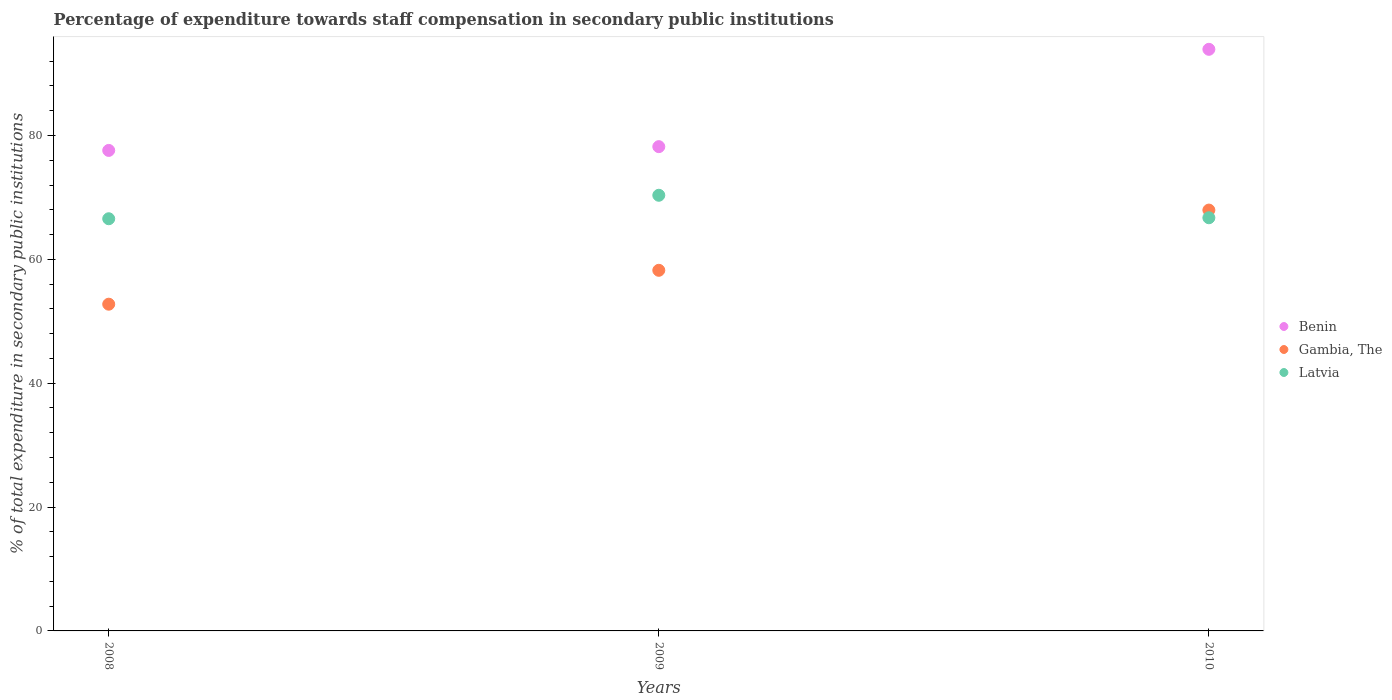Is the number of dotlines equal to the number of legend labels?
Make the answer very short. Yes. What is the percentage of expenditure towards staff compensation in Benin in 2010?
Provide a short and direct response. 93.91. Across all years, what is the maximum percentage of expenditure towards staff compensation in Gambia, The?
Your response must be concise. 67.96. Across all years, what is the minimum percentage of expenditure towards staff compensation in Latvia?
Your answer should be compact. 66.56. In which year was the percentage of expenditure towards staff compensation in Benin maximum?
Give a very brief answer. 2010. What is the total percentage of expenditure towards staff compensation in Latvia in the graph?
Offer a very short reply. 203.62. What is the difference between the percentage of expenditure towards staff compensation in Benin in 2009 and that in 2010?
Offer a terse response. -15.72. What is the difference between the percentage of expenditure towards staff compensation in Latvia in 2008 and the percentage of expenditure towards staff compensation in Benin in 2010?
Ensure brevity in your answer.  -27.36. What is the average percentage of expenditure towards staff compensation in Gambia, The per year?
Make the answer very short. 59.65. In the year 2009, what is the difference between the percentage of expenditure towards staff compensation in Gambia, The and percentage of expenditure towards staff compensation in Latvia?
Ensure brevity in your answer.  -12.12. What is the ratio of the percentage of expenditure towards staff compensation in Benin in 2009 to that in 2010?
Your answer should be very brief. 0.83. What is the difference between the highest and the second highest percentage of expenditure towards staff compensation in Latvia?
Provide a succinct answer. 3.63. What is the difference between the highest and the lowest percentage of expenditure towards staff compensation in Gambia, The?
Keep it short and to the point. 15.2. In how many years, is the percentage of expenditure towards staff compensation in Benin greater than the average percentage of expenditure towards staff compensation in Benin taken over all years?
Offer a terse response. 1. Is it the case that in every year, the sum of the percentage of expenditure towards staff compensation in Benin and percentage of expenditure towards staff compensation in Latvia  is greater than the percentage of expenditure towards staff compensation in Gambia, The?
Give a very brief answer. Yes. How many dotlines are there?
Provide a short and direct response. 3. Are the values on the major ticks of Y-axis written in scientific E-notation?
Provide a succinct answer. No. Does the graph contain grids?
Provide a short and direct response. No. Where does the legend appear in the graph?
Offer a very short reply. Center right. How many legend labels are there?
Keep it short and to the point. 3. How are the legend labels stacked?
Your response must be concise. Vertical. What is the title of the graph?
Offer a very short reply. Percentage of expenditure towards staff compensation in secondary public institutions. Does "Montenegro" appear as one of the legend labels in the graph?
Your response must be concise. No. What is the label or title of the X-axis?
Provide a short and direct response. Years. What is the label or title of the Y-axis?
Offer a terse response. % of total expenditure in secondary public institutions. What is the % of total expenditure in secondary public institutions of Benin in 2008?
Offer a very short reply. 77.59. What is the % of total expenditure in secondary public institutions in Gambia, The in 2008?
Offer a terse response. 52.76. What is the % of total expenditure in secondary public institutions of Latvia in 2008?
Ensure brevity in your answer.  66.56. What is the % of total expenditure in secondary public institutions in Benin in 2009?
Your answer should be very brief. 78.2. What is the % of total expenditure in secondary public institutions in Gambia, The in 2009?
Keep it short and to the point. 58.23. What is the % of total expenditure in secondary public institutions in Latvia in 2009?
Provide a succinct answer. 70.35. What is the % of total expenditure in secondary public institutions of Benin in 2010?
Offer a terse response. 93.91. What is the % of total expenditure in secondary public institutions of Gambia, The in 2010?
Provide a succinct answer. 67.96. What is the % of total expenditure in secondary public institutions of Latvia in 2010?
Keep it short and to the point. 66.72. Across all years, what is the maximum % of total expenditure in secondary public institutions of Benin?
Provide a short and direct response. 93.91. Across all years, what is the maximum % of total expenditure in secondary public institutions of Gambia, The?
Keep it short and to the point. 67.96. Across all years, what is the maximum % of total expenditure in secondary public institutions of Latvia?
Your answer should be compact. 70.35. Across all years, what is the minimum % of total expenditure in secondary public institutions of Benin?
Your answer should be very brief. 77.59. Across all years, what is the minimum % of total expenditure in secondary public institutions in Gambia, The?
Provide a succinct answer. 52.76. Across all years, what is the minimum % of total expenditure in secondary public institutions of Latvia?
Your response must be concise. 66.56. What is the total % of total expenditure in secondary public institutions in Benin in the graph?
Make the answer very short. 249.7. What is the total % of total expenditure in secondary public institutions in Gambia, The in the graph?
Keep it short and to the point. 178.95. What is the total % of total expenditure in secondary public institutions of Latvia in the graph?
Make the answer very short. 203.62. What is the difference between the % of total expenditure in secondary public institutions of Benin in 2008 and that in 2009?
Your answer should be compact. -0.61. What is the difference between the % of total expenditure in secondary public institutions in Gambia, The in 2008 and that in 2009?
Your answer should be very brief. -5.47. What is the difference between the % of total expenditure in secondary public institutions in Latvia in 2008 and that in 2009?
Provide a short and direct response. -3.79. What is the difference between the % of total expenditure in secondary public institutions in Benin in 2008 and that in 2010?
Your answer should be compact. -16.33. What is the difference between the % of total expenditure in secondary public institutions in Gambia, The in 2008 and that in 2010?
Ensure brevity in your answer.  -15.2. What is the difference between the % of total expenditure in secondary public institutions in Latvia in 2008 and that in 2010?
Give a very brief answer. -0.16. What is the difference between the % of total expenditure in secondary public institutions in Benin in 2009 and that in 2010?
Your answer should be very brief. -15.72. What is the difference between the % of total expenditure in secondary public institutions of Gambia, The in 2009 and that in 2010?
Make the answer very short. -9.73. What is the difference between the % of total expenditure in secondary public institutions in Latvia in 2009 and that in 2010?
Offer a very short reply. 3.63. What is the difference between the % of total expenditure in secondary public institutions in Benin in 2008 and the % of total expenditure in secondary public institutions in Gambia, The in 2009?
Your answer should be very brief. 19.36. What is the difference between the % of total expenditure in secondary public institutions in Benin in 2008 and the % of total expenditure in secondary public institutions in Latvia in 2009?
Provide a succinct answer. 7.24. What is the difference between the % of total expenditure in secondary public institutions in Gambia, The in 2008 and the % of total expenditure in secondary public institutions in Latvia in 2009?
Give a very brief answer. -17.59. What is the difference between the % of total expenditure in secondary public institutions in Benin in 2008 and the % of total expenditure in secondary public institutions in Gambia, The in 2010?
Your answer should be compact. 9.63. What is the difference between the % of total expenditure in secondary public institutions in Benin in 2008 and the % of total expenditure in secondary public institutions in Latvia in 2010?
Give a very brief answer. 10.87. What is the difference between the % of total expenditure in secondary public institutions in Gambia, The in 2008 and the % of total expenditure in secondary public institutions in Latvia in 2010?
Keep it short and to the point. -13.96. What is the difference between the % of total expenditure in secondary public institutions in Benin in 2009 and the % of total expenditure in secondary public institutions in Gambia, The in 2010?
Provide a succinct answer. 10.24. What is the difference between the % of total expenditure in secondary public institutions in Benin in 2009 and the % of total expenditure in secondary public institutions in Latvia in 2010?
Provide a succinct answer. 11.48. What is the difference between the % of total expenditure in secondary public institutions in Gambia, The in 2009 and the % of total expenditure in secondary public institutions in Latvia in 2010?
Provide a succinct answer. -8.49. What is the average % of total expenditure in secondary public institutions of Benin per year?
Make the answer very short. 83.23. What is the average % of total expenditure in secondary public institutions in Gambia, The per year?
Your response must be concise. 59.65. What is the average % of total expenditure in secondary public institutions in Latvia per year?
Offer a terse response. 67.87. In the year 2008, what is the difference between the % of total expenditure in secondary public institutions in Benin and % of total expenditure in secondary public institutions in Gambia, The?
Ensure brevity in your answer.  24.83. In the year 2008, what is the difference between the % of total expenditure in secondary public institutions of Benin and % of total expenditure in secondary public institutions of Latvia?
Make the answer very short. 11.03. In the year 2008, what is the difference between the % of total expenditure in secondary public institutions in Gambia, The and % of total expenditure in secondary public institutions in Latvia?
Your answer should be compact. -13.8. In the year 2009, what is the difference between the % of total expenditure in secondary public institutions of Benin and % of total expenditure in secondary public institutions of Gambia, The?
Provide a succinct answer. 19.97. In the year 2009, what is the difference between the % of total expenditure in secondary public institutions in Benin and % of total expenditure in secondary public institutions in Latvia?
Provide a succinct answer. 7.85. In the year 2009, what is the difference between the % of total expenditure in secondary public institutions of Gambia, The and % of total expenditure in secondary public institutions of Latvia?
Make the answer very short. -12.12. In the year 2010, what is the difference between the % of total expenditure in secondary public institutions of Benin and % of total expenditure in secondary public institutions of Gambia, The?
Make the answer very short. 25.96. In the year 2010, what is the difference between the % of total expenditure in secondary public institutions of Benin and % of total expenditure in secondary public institutions of Latvia?
Keep it short and to the point. 27.2. In the year 2010, what is the difference between the % of total expenditure in secondary public institutions in Gambia, The and % of total expenditure in secondary public institutions in Latvia?
Keep it short and to the point. 1.24. What is the ratio of the % of total expenditure in secondary public institutions of Gambia, The in 2008 to that in 2009?
Ensure brevity in your answer.  0.91. What is the ratio of the % of total expenditure in secondary public institutions in Latvia in 2008 to that in 2009?
Offer a terse response. 0.95. What is the ratio of the % of total expenditure in secondary public institutions in Benin in 2008 to that in 2010?
Your response must be concise. 0.83. What is the ratio of the % of total expenditure in secondary public institutions in Gambia, The in 2008 to that in 2010?
Offer a terse response. 0.78. What is the ratio of the % of total expenditure in secondary public institutions of Benin in 2009 to that in 2010?
Offer a very short reply. 0.83. What is the ratio of the % of total expenditure in secondary public institutions of Gambia, The in 2009 to that in 2010?
Offer a very short reply. 0.86. What is the ratio of the % of total expenditure in secondary public institutions of Latvia in 2009 to that in 2010?
Give a very brief answer. 1.05. What is the difference between the highest and the second highest % of total expenditure in secondary public institutions in Benin?
Your answer should be compact. 15.72. What is the difference between the highest and the second highest % of total expenditure in secondary public institutions of Gambia, The?
Your answer should be very brief. 9.73. What is the difference between the highest and the second highest % of total expenditure in secondary public institutions of Latvia?
Keep it short and to the point. 3.63. What is the difference between the highest and the lowest % of total expenditure in secondary public institutions in Benin?
Offer a terse response. 16.33. What is the difference between the highest and the lowest % of total expenditure in secondary public institutions of Gambia, The?
Make the answer very short. 15.2. What is the difference between the highest and the lowest % of total expenditure in secondary public institutions in Latvia?
Your answer should be compact. 3.79. 